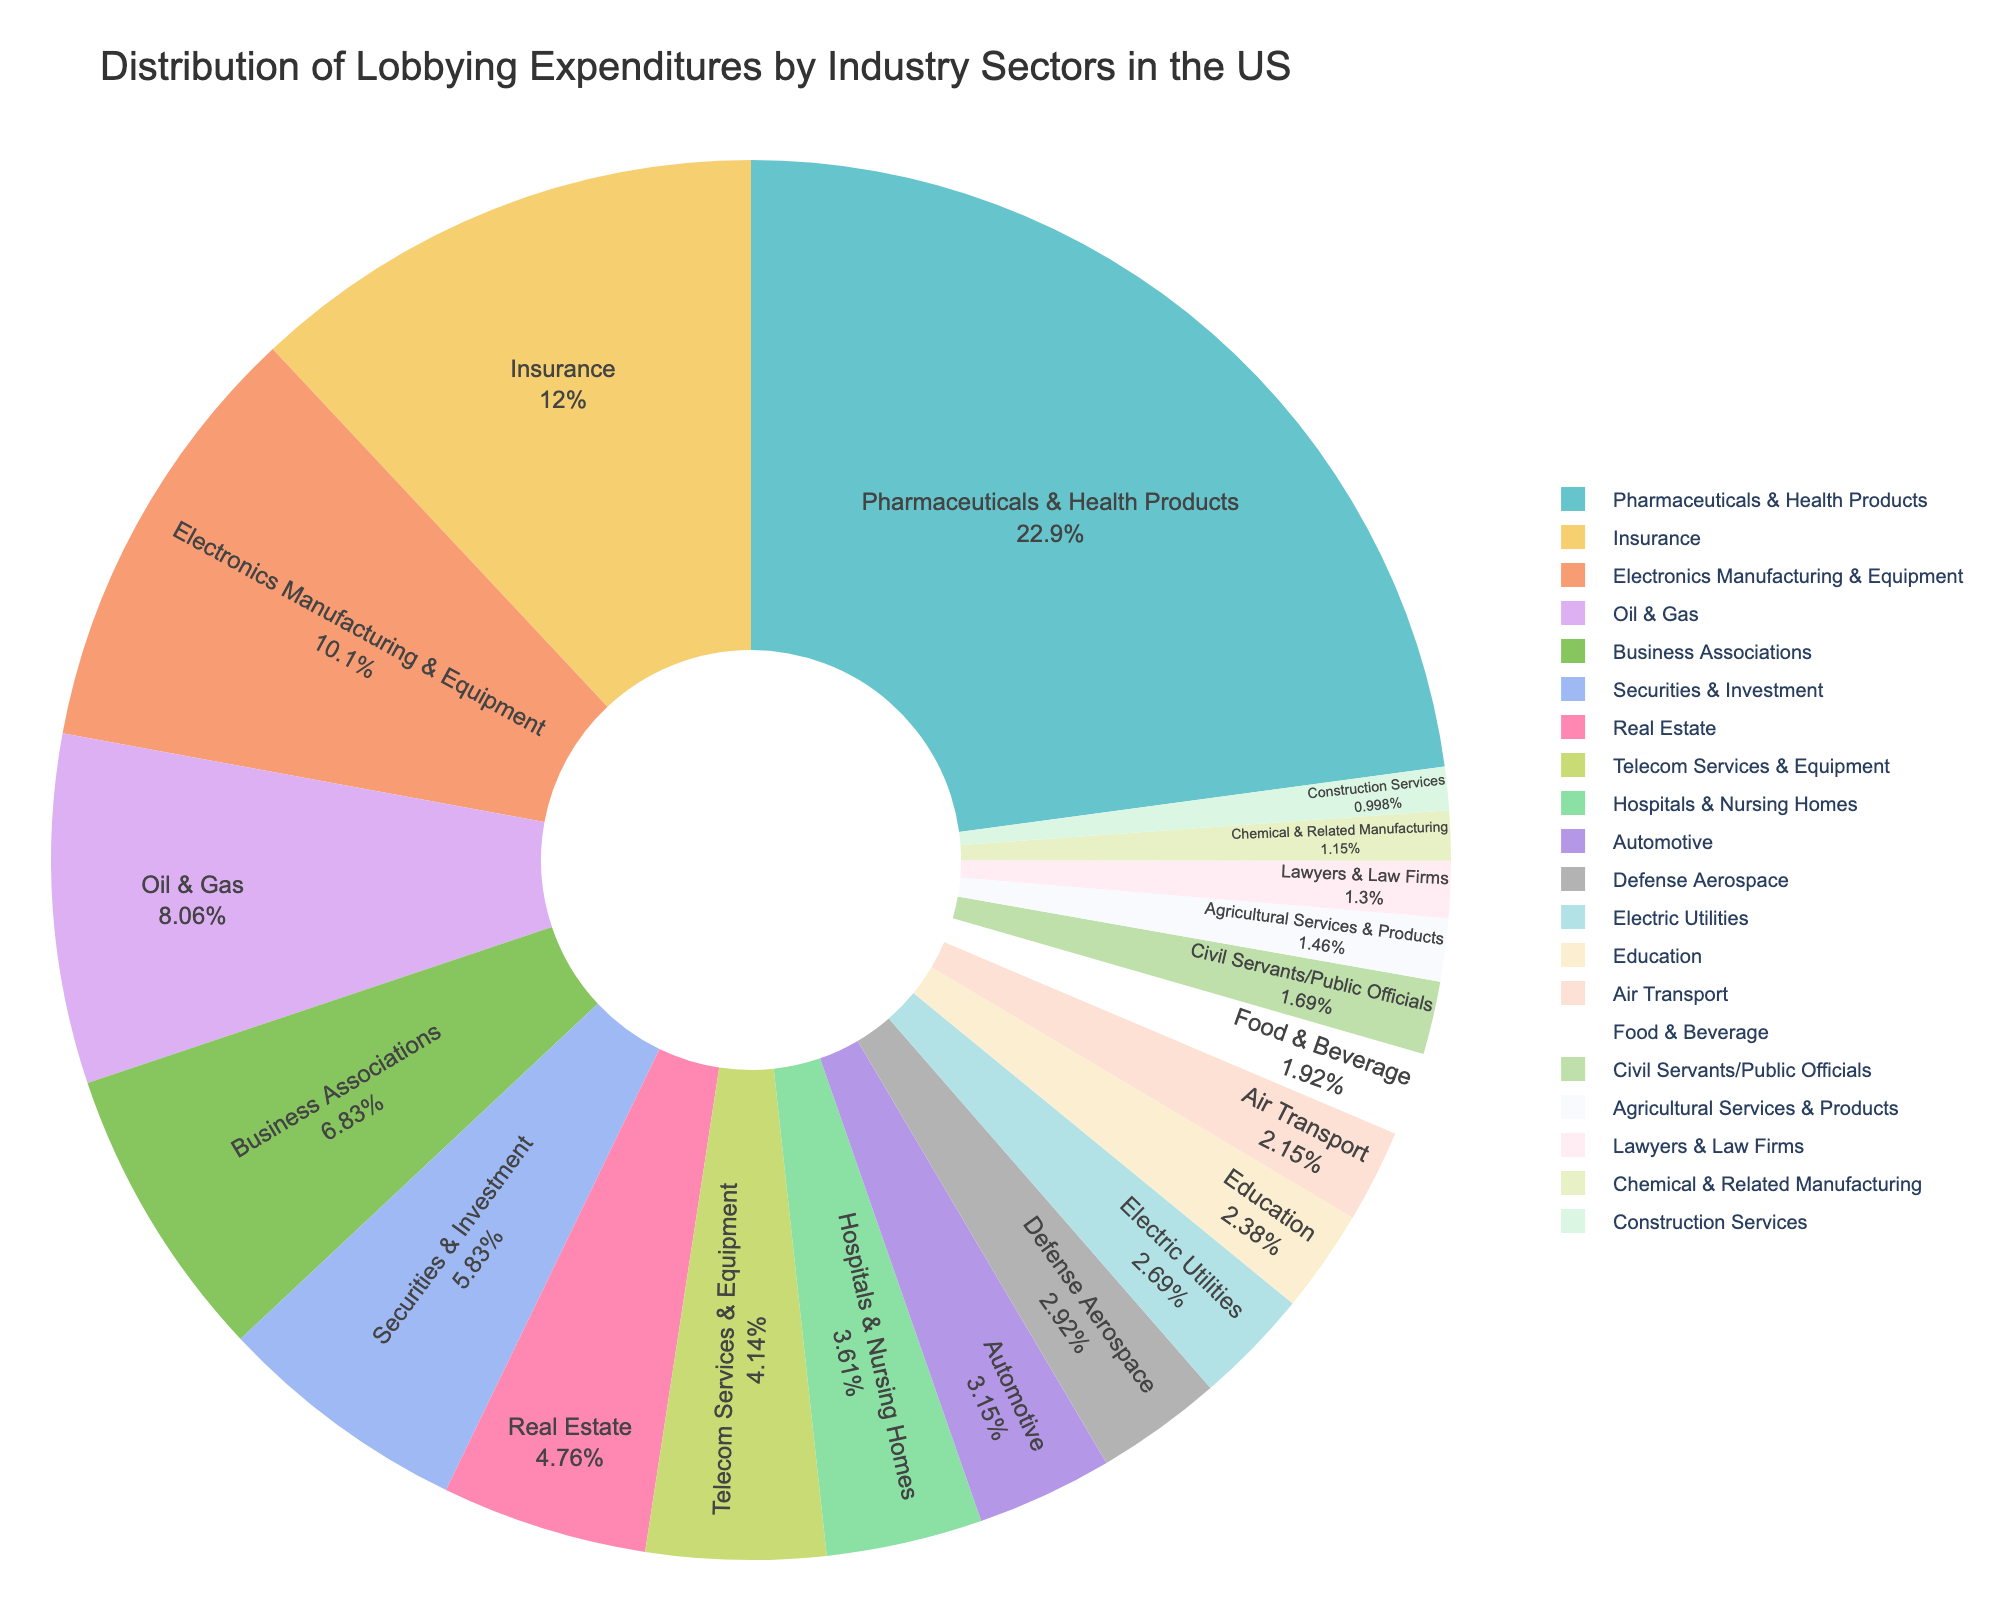Which industry has the highest lobbying expenditure? The pie chart shows various industry sectors, and the largest segment represents the highest value. By identifying this segment, we see that Pharmaceuticals & Health Products have the highest lobbying expenditure at $298 million.
Answer: Pharmaceuticals & Health Products What is the combined lobbying expenditure of the Oil & Gas and Education sectors? From the pie chart, the expenditure for Oil & Gas is $105 million and for Education is $31 million. Adding these amounts together gives $105 million + $31 million = $136 million.
Answer: $136 million How does the lobbying expenditure for the Telecom Services & Equipment sector compare to the Real Estate sector? The pie chart shows that Telecom Services & Equipment has an expenditure of $54 million, while Real Estate has $62 million. Comparing these values, Real Estate spends more on lobbying than Telecom Services & Equipment.
Answer: Real Estate spends more What percentage of the total lobbying expenditure is contributed by the top three industry sectors? The top three sectors are Pharmaceuticals & Health Products ($298 million), Insurance ($156 million), and Electronics Manufacturing & Equipment ($132 million). The total expenditure is the sum of all sectors, which is $1275 million. The contribution of the top three is ($298 + $156 + $132) / $1275 * 100 = 46.4%.
Answer: 46.4% Which industry sectors have a lobbying expenditure less than $30 million? To find this, look at the pie chart for sectors with smaller segments indicating expenditures below $30 million. These are Agricultural Services & Products ($19 million), Lawyers & Law Firms ($17 million), Chemical & Related Manufacturing ($15 million), and Construction Services ($13 million).
Answer: Agricultural Services & Products, Lawyers & Law Firms, Chemical & Related Manufacturing, Construction Services What is the difference in lobbying expenditures between the Pharmaceuticals & Health Products sector and the Automotive sector? The Pharmaceuticals & Health Products sector's expenditure is $298 million, while the Automotive sector's expenditure is $41 million. Subtracting the smaller from the larger gives $298 million - $41 million = $257 million.
Answer: $257 million How much more does the Insurance industry spend on lobbying compared to the Electric Utilities industry? From the pie chart, the Insurance industry's expenditure is $156 million, and the Electric Utilities industry's expenditure is $35 million. The difference is $156 million - $35 million = $121 million.
Answer: $121 million Which sector has the smallest lobbying expenditure and what is it? By looking at the smallest segment of the pie chart, the Construction Services sector has the smallest lobbying expenditure, which is $13 million.
Answer: Construction Services, $13 million 